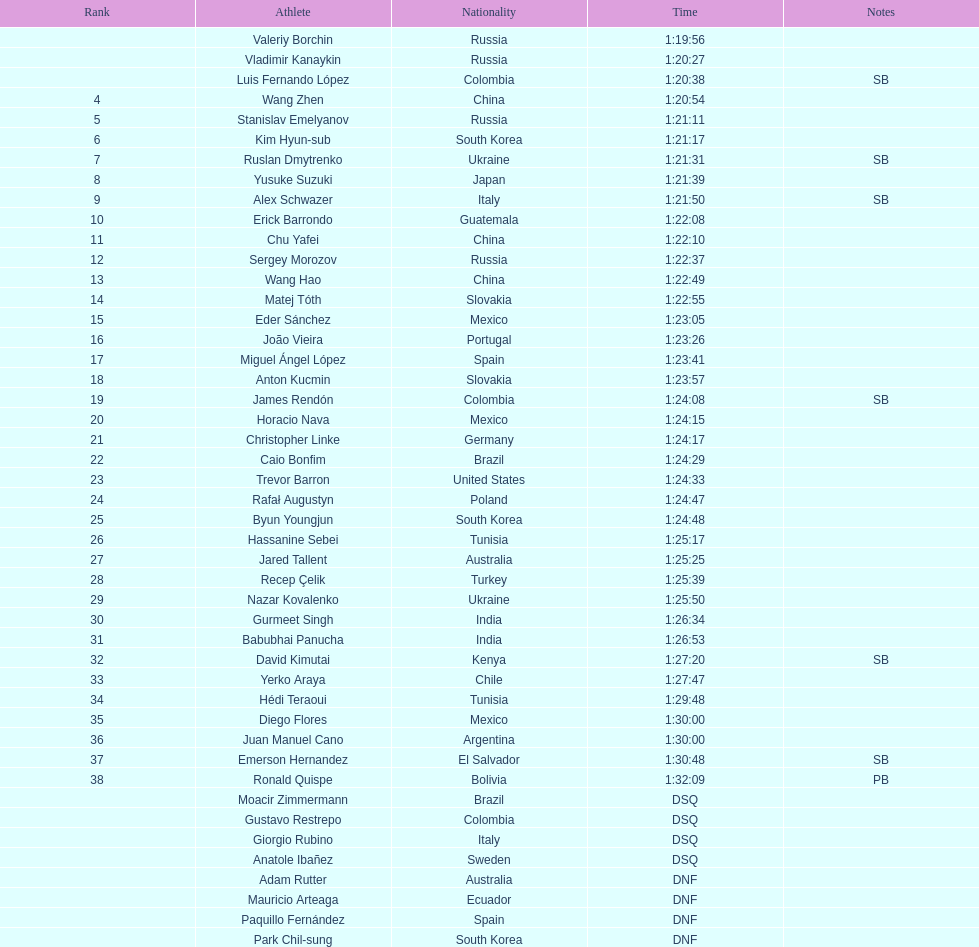Help me parse the entirety of this table. {'header': ['Rank', 'Athlete', 'Nationality', 'Time', 'Notes'], 'rows': [['', 'Valeriy Borchin', 'Russia', '1:19:56', ''], ['', 'Vladimir Kanaykin', 'Russia', '1:20:27', ''], ['', 'Luis Fernando López', 'Colombia', '1:20:38', 'SB'], ['4', 'Wang Zhen', 'China', '1:20:54', ''], ['5', 'Stanislav Emelyanov', 'Russia', '1:21:11', ''], ['6', 'Kim Hyun-sub', 'South Korea', '1:21:17', ''], ['7', 'Ruslan Dmytrenko', 'Ukraine', '1:21:31', 'SB'], ['8', 'Yusuke Suzuki', 'Japan', '1:21:39', ''], ['9', 'Alex Schwazer', 'Italy', '1:21:50', 'SB'], ['10', 'Erick Barrondo', 'Guatemala', '1:22:08', ''], ['11', 'Chu Yafei', 'China', '1:22:10', ''], ['12', 'Sergey Morozov', 'Russia', '1:22:37', ''], ['13', 'Wang Hao', 'China', '1:22:49', ''], ['14', 'Matej Tóth', 'Slovakia', '1:22:55', ''], ['15', 'Eder Sánchez', 'Mexico', '1:23:05', ''], ['16', 'João Vieira', 'Portugal', '1:23:26', ''], ['17', 'Miguel Ángel López', 'Spain', '1:23:41', ''], ['18', 'Anton Kucmin', 'Slovakia', '1:23:57', ''], ['19', 'James Rendón', 'Colombia', '1:24:08', 'SB'], ['20', 'Horacio Nava', 'Mexico', '1:24:15', ''], ['21', 'Christopher Linke', 'Germany', '1:24:17', ''], ['22', 'Caio Bonfim', 'Brazil', '1:24:29', ''], ['23', 'Trevor Barron', 'United States', '1:24:33', ''], ['24', 'Rafał Augustyn', 'Poland', '1:24:47', ''], ['25', 'Byun Youngjun', 'South Korea', '1:24:48', ''], ['26', 'Hassanine Sebei', 'Tunisia', '1:25:17', ''], ['27', 'Jared Tallent', 'Australia', '1:25:25', ''], ['28', 'Recep Çelik', 'Turkey', '1:25:39', ''], ['29', 'Nazar Kovalenko', 'Ukraine', '1:25:50', ''], ['30', 'Gurmeet Singh', 'India', '1:26:34', ''], ['31', 'Babubhai Panucha', 'India', '1:26:53', ''], ['32', 'David Kimutai', 'Kenya', '1:27:20', 'SB'], ['33', 'Yerko Araya', 'Chile', '1:27:47', ''], ['34', 'Hédi Teraoui', 'Tunisia', '1:29:48', ''], ['35', 'Diego Flores', 'Mexico', '1:30:00', ''], ['36', 'Juan Manuel Cano', 'Argentina', '1:30:00', ''], ['37', 'Emerson Hernandez', 'El Salvador', '1:30:48', 'SB'], ['38', 'Ronald Quispe', 'Bolivia', '1:32:09', 'PB'], ['', 'Moacir Zimmermann', 'Brazil', 'DSQ', ''], ['', 'Gustavo Restrepo', 'Colombia', 'DSQ', ''], ['', 'Giorgio Rubino', 'Italy', 'DSQ', ''], ['', 'Anatole Ibañez', 'Sweden', 'DSQ', ''], ['', 'Adam Rutter', 'Australia', 'DNF', ''], ['', 'Mauricio Arteaga', 'Ecuador', 'DNF', ''], ['', 'Paquillo Fernández', 'Spain', 'DNF', ''], ['', 'Park Chil-sung', 'South Korea', 'DNF', '']]} Which competitor was ranked first? Valeriy Borchin. 